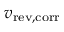Convert formula to latex. <formula><loc_0><loc_0><loc_500><loc_500>v _ { r e v , c o r r }</formula> 